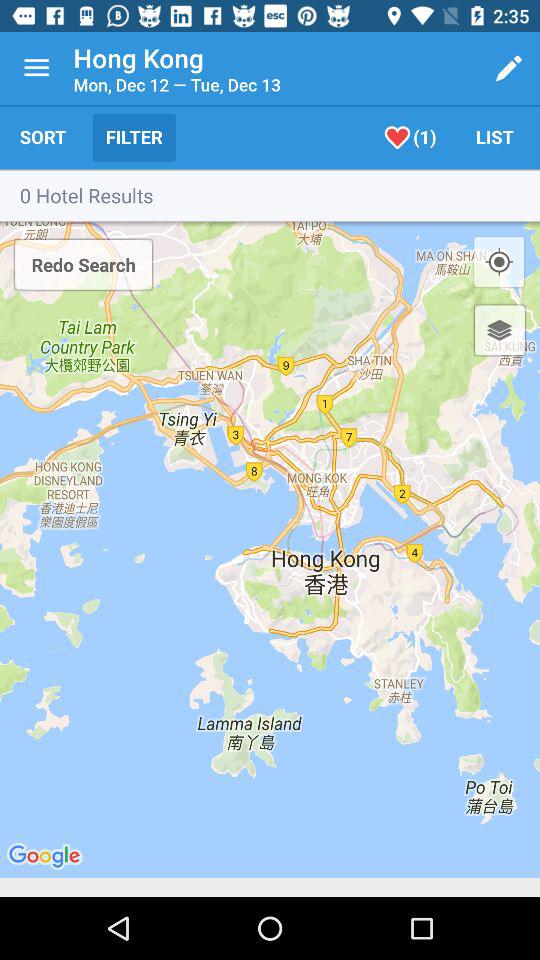What is the name of the country that appears on the map?
When the provided information is insufficient, respond with <no answer>. <no answer> 